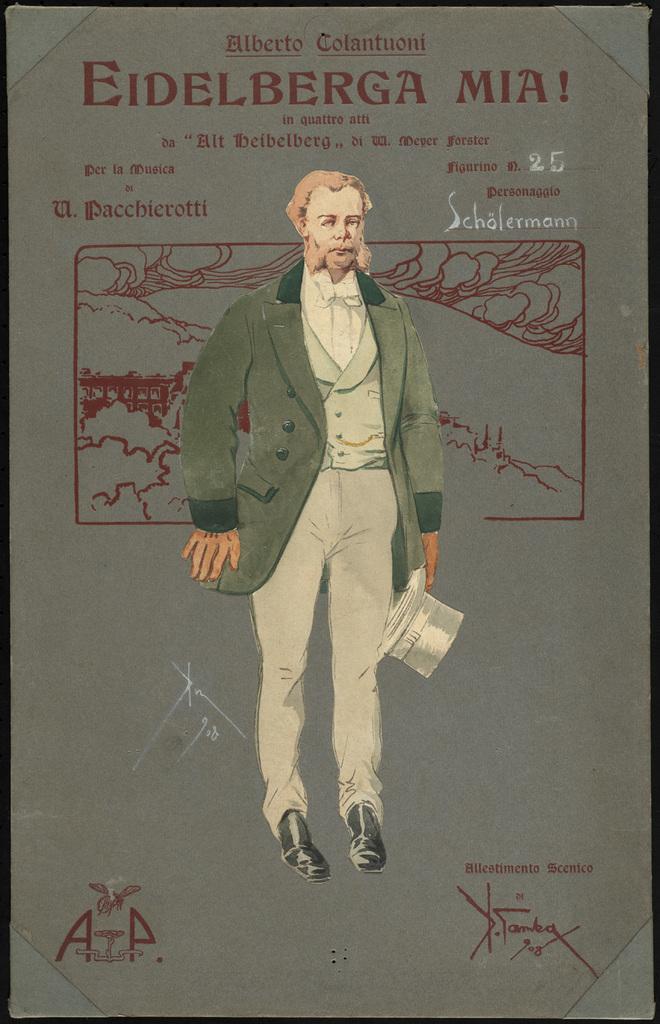Describe this image in one or two sentences. In this picture we can see a sketch of a man holding a hat and standing on the ground. In the background we can see the drawing of some other objects and there is text on the image. 